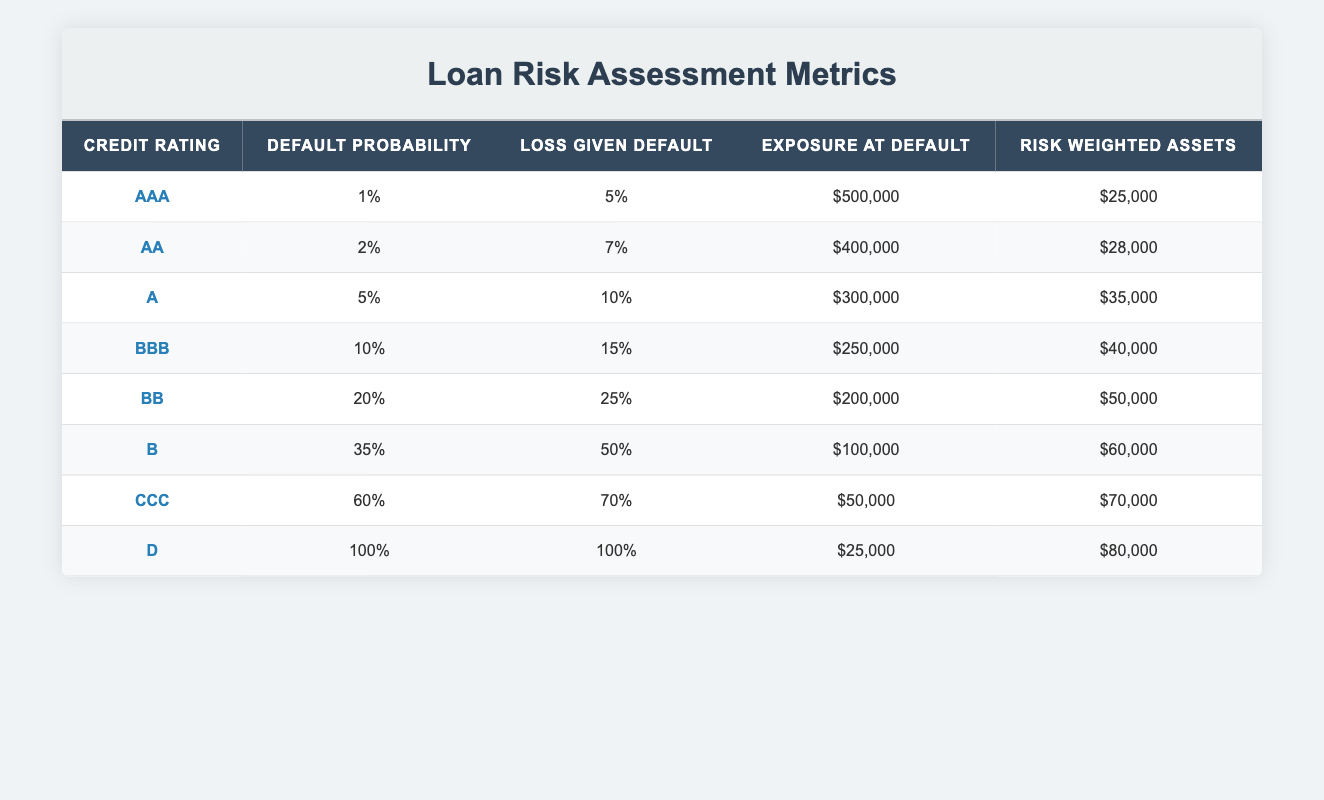What is the default probability for a loan with a credit rating of AA? The default probability for the credit rating AA is listed directly in the table under the Default Probability column. Referring to the row for AA, it shows a value of 0.02, or 2%.
Answer: 2% What is the loss given default for loans rated BBB? The loss given default for BBB can be found in the specific row associated with that credit rating. The corresponding value in the Loss Given Default column is 0.15, or 15%.
Answer: 15% How much is the exposure at default for the lowest credit rating? The lowest credit rating in the table is D, and the corresponding exposure at default is listed in its row. Looking at D, the value is $25,000.
Answer: $25,000 What is the average default probability for credit ratings from AAA to A? To find the average default probability for credit ratings AAA, AA, and A, we first identify their default probabilities: AAA = 0.01, AA = 0.02, A = 0.05. We then add these values: 0.01 + 0.02 + 0.05 = 0.08. There are 3 ratings, so we divide the sum by 3 to find the average: 0.08 / 3 = 0.0267, or approximately 2.67%.
Answer: 2.67% Is there any credit rating with a default probability higher than 50%? We can check each credit rating and its corresponding default probability to see if any exceed 50%. Looking at the ratings, CCC has a default probability of 0.60 and D has 1.00, which both exceed 50%. Thus, the statement is true.
Answer: Yes How do the risk weighted assets for credit rating B compare to those for AAA? The risk weighted assets for B and AAA can be found in their respective rows. For B, the risk weighted assets are $60,000, while for AAA, they are $25,000. To compare, we subtract: $60,000 - $25,000 = $35,000, indicating B has $35,000 more in risk weighted assets than AAA.
Answer: $35,000 more What is the total exposure at default for credit ratings from BB to D? To find the total exposure at default for BB, B, CCC, and D, we locate their values: BB = $200,000, B = $100,000, CCC = $50,000, and D = $25,000. We add these values together: $200,000 + $100,000 + $50,000 + $25,000 = $375,000. Thus, the total exposure at default is $375,000.
Answer: $375,000 Is the loss given default for credit rating B lower than that for credit rating CCC? By checking the values in the Loss Given Default column, we find that for B it's 0.50 (50%) and for CCC it's 0.70 (70%). Since 50% is less than 70%, the statement is true.
Answer: No Which credit rating has the highest loss given default? The highest loss given default can be identified by checking the Loss Given Default column. The values are: AAA = 0.05, AA = 0.07, A = 0.10, BBB = 0.15, BB = 0.25, B = 0.50, CCC = 0.70, and D = 1.00. The highest value is 1.00 for credit rating D.
Answer: D 